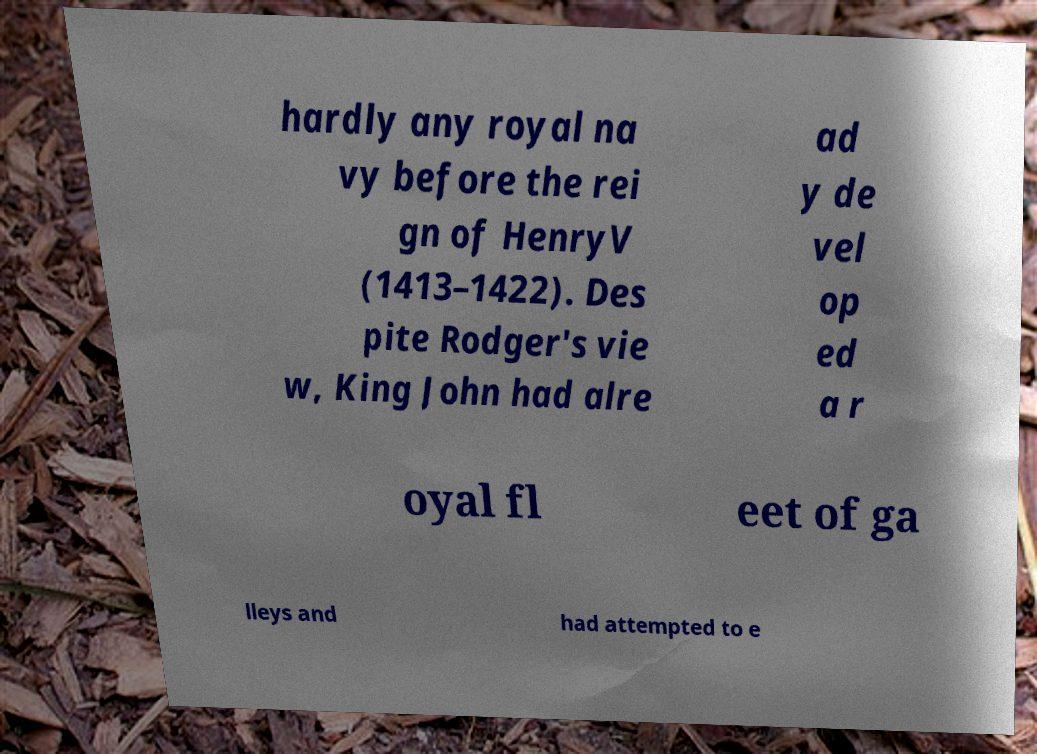For documentation purposes, I need the text within this image transcribed. Could you provide that? hardly any royal na vy before the rei gn of HenryV (1413–1422). Des pite Rodger's vie w, King John had alre ad y de vel op ed a r oyal fl eet of ga lleys and had attempted to e 